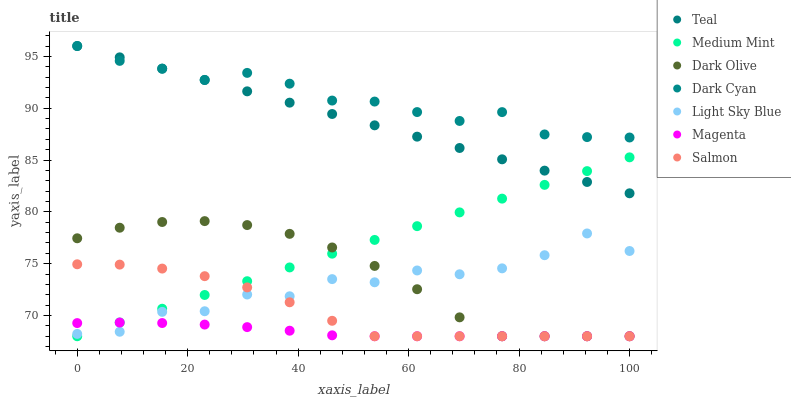Does Magenta have the minimum area under the curve?
Answer yes or no. Yes. Does Dark Cyan have the maximum area under the curve?
Answer yes or no. Yes. Does Dark Olive have the minimum area under the curve?
Answer yes or no. No. Does Dark Olive have the maximum area under the curve?
Answer yes or no. No. Is Teal the smoothest?
Answer yes or no. Yes. Is Light Sky Blue the roughest?
Answer yes or no. Yes. Is Dark Olive the smoothest?
Answer yes or no. No. Is Dark Olive the roughest?
Answer yes or no. No. Does Medium Mint have the lowest value?
Answer yes or no. Yes. Does Light Sky Blue have the lowest value?
Answer yes or no. No. Does Dark Cyan have the highest value?
Answer yes or no. Yes. Does Dark Olive have the highest value?
Answer yes or no. No. Is Salmon less than Dark Cyan?
Answer yes or no. Yes. Is Teal greater than Salmon?
Answer yes or no. Yes. Does Medium Mint intersect Teal?
Answer yes or no. Yes. Is Medium Mint less than Teal?
Answer yes or no. No. Is Medium Mint greater than Teal?
Answer yes or no. No. Does Salmon intersect Dark Cyan?
Answer yes or no. No. 